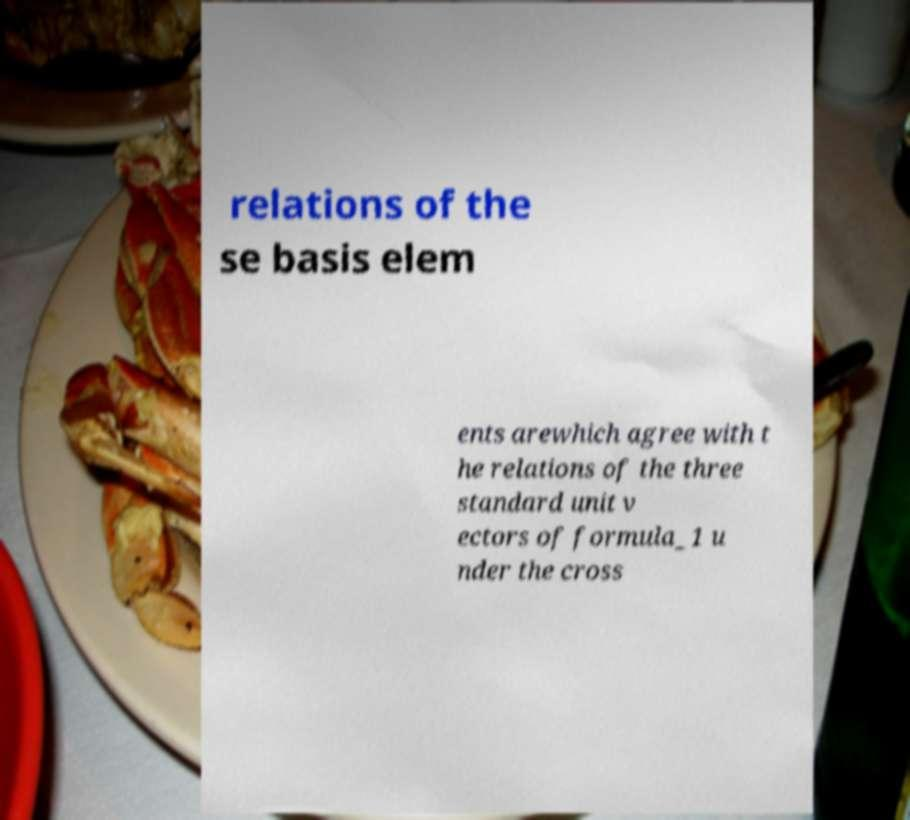Could you assist in decoding the text presented in this image and type it out clearly? relations of the se basis elem ents arewhich agree with t he relations of the three standard unit v ectors of formula_1 u nder the cross 